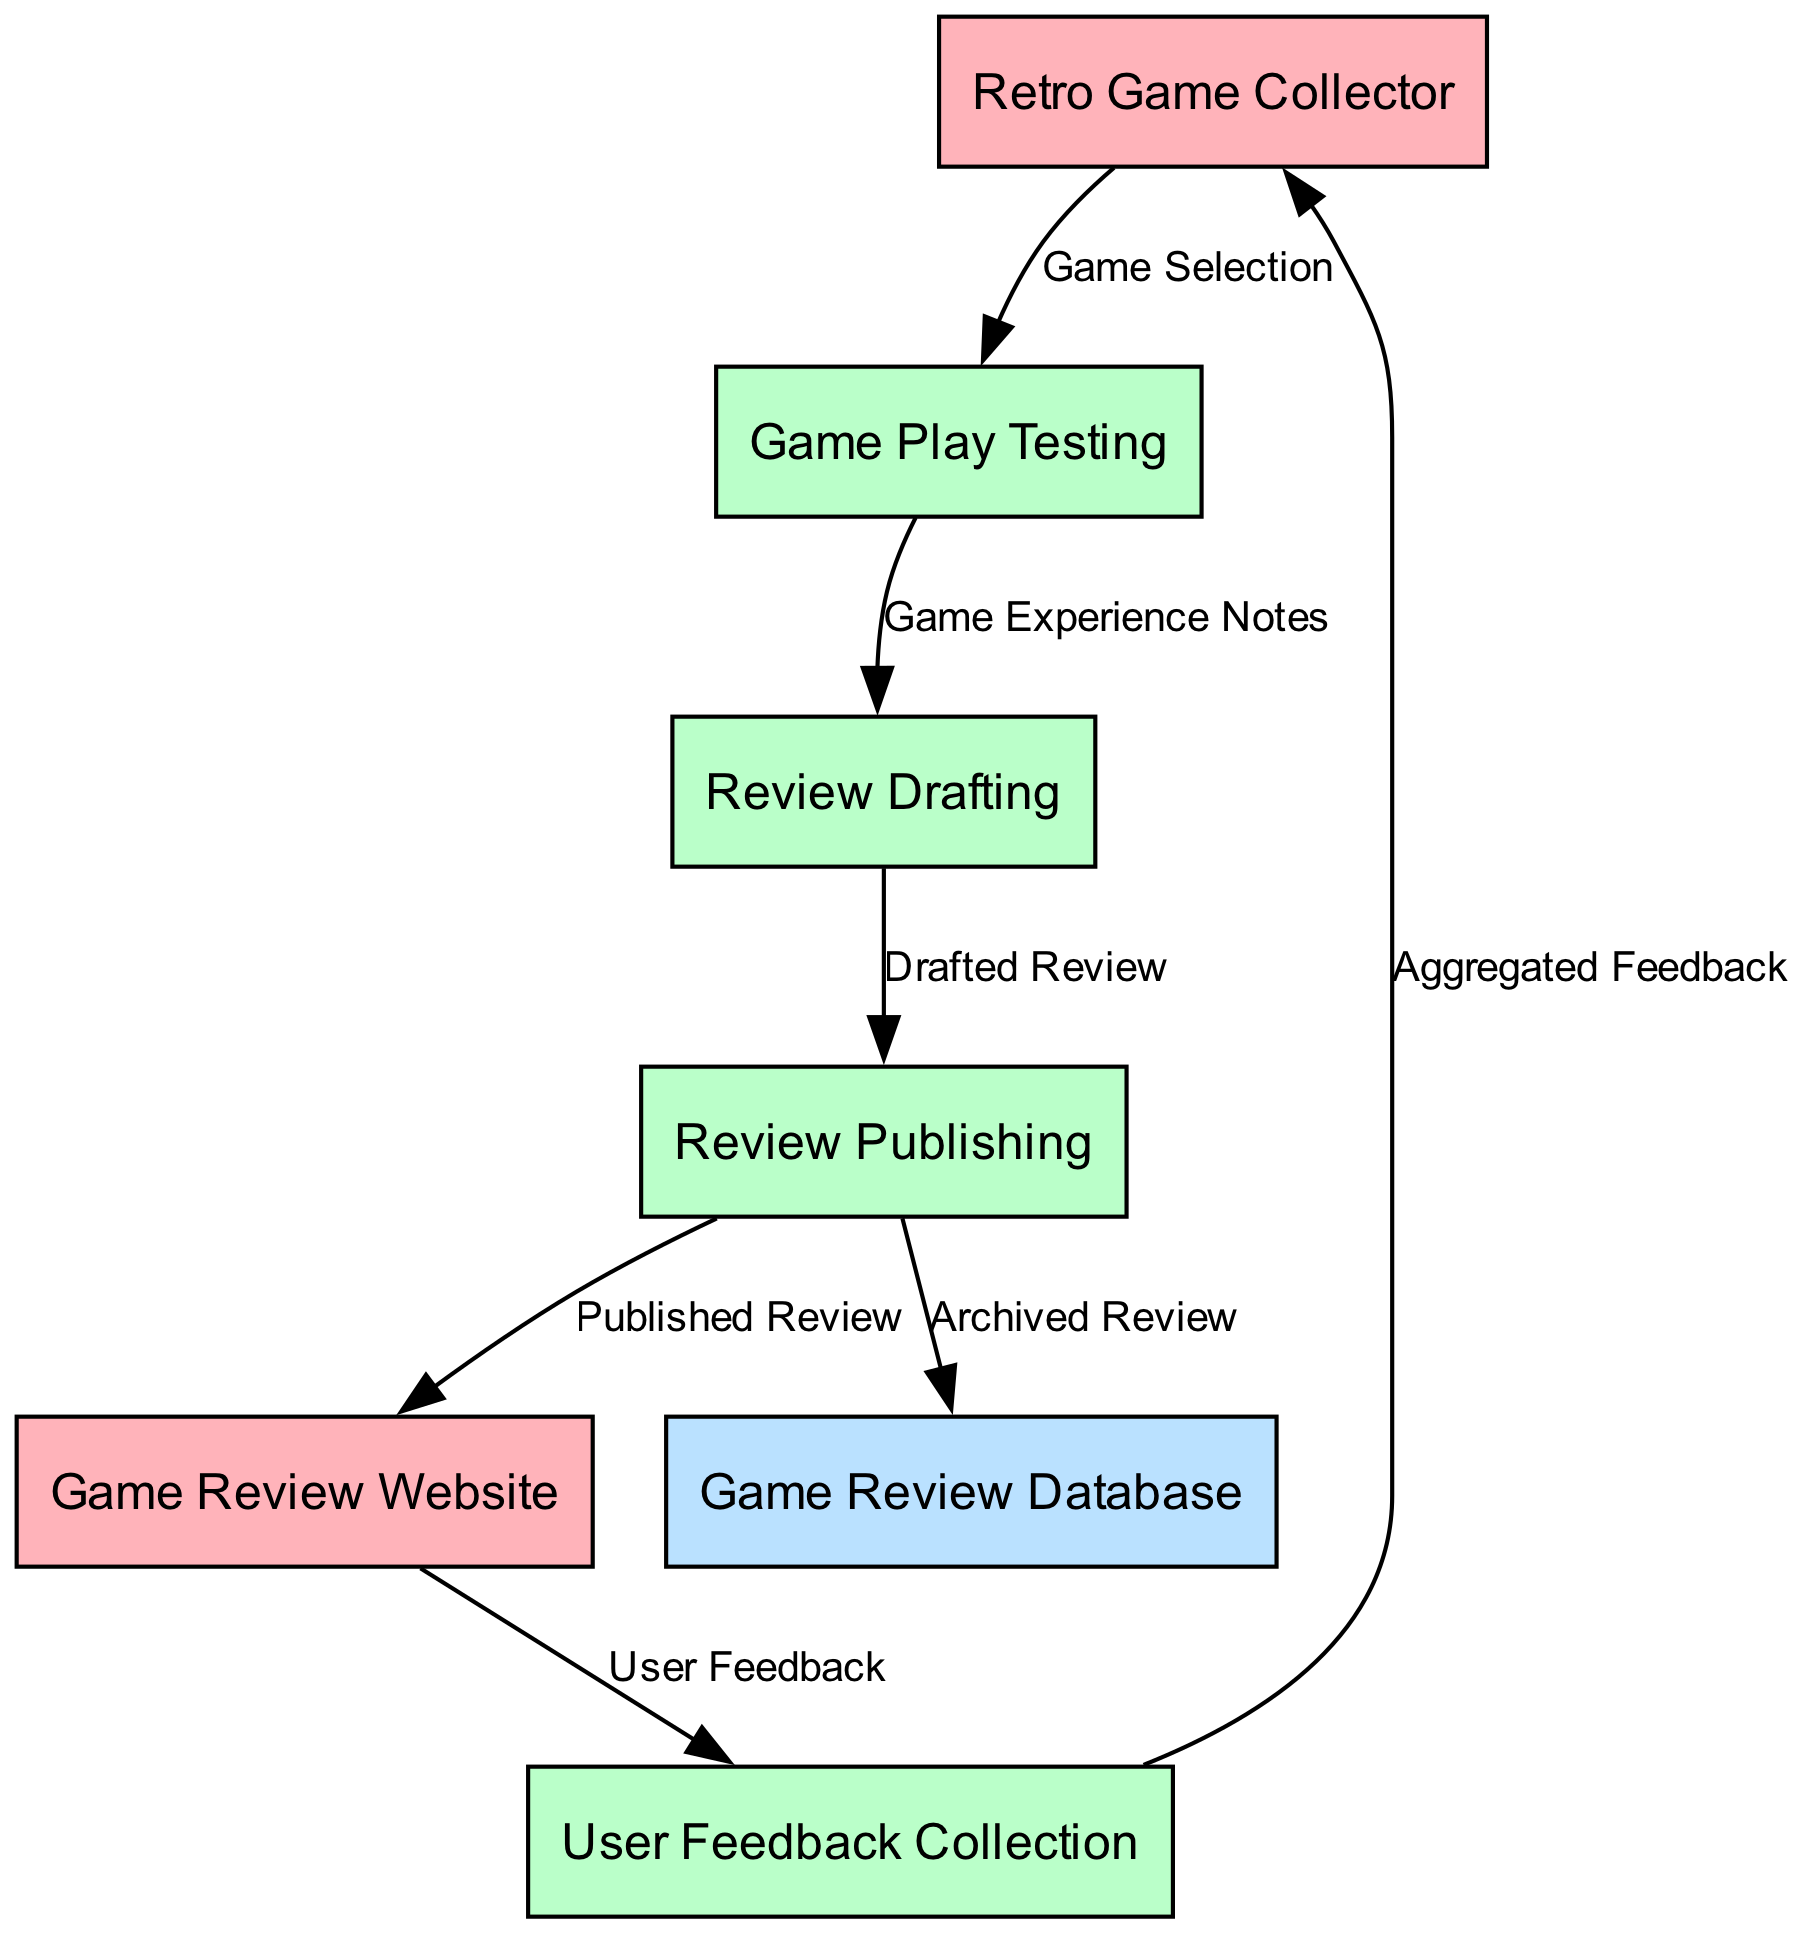What is the total number of nodes in the diagram? The diagram contains six different entities and processes, which are: Retro Game Collector, Game Review Website, Game Review Database, Game Play Testing, Review Drafting, and Review Publishing. Therefore, the total number of nodes is six.
Answer: 6 What type of node is "Game Review Database"? In the diagram, "Game Review Database" is classified under the type "Data Store", as it is used to store archived reviews and serves as a repository for the game reviews.
Answer: Data Store What data flows from "Game Play Testing" to "Review Drafting"? The data that flows from "Game Play Testing" to "Review Drafting" is described as "Game Experience Notes", which represent the information collected during the game play testing process.
Answer: Game Experience Notes Which node sends "User Feedback" to "User Feedback Collection"? The node that sends "User Feedback" to "User Feedback Collection" is the "Game Review Website". It collects feedback from users who have read the reviews and inputs it into the feedback collection process.
Answer: Game Review Website What is the final output of the "Review Publishing" process? The final outputs of the "Review Publishing" process are twofold: it produces a "Published Review" that gets sent to the "Game Review Website" and an "Archived Review" that goes to the "Game Review Database". Thus, the final outputs include both these reviews.
Answer: Published Review, Archived Review What is the order of processes after "Game Play Testing"? The processes that follow "Game Play Testing" in order are: "Review Drafting", then "Review Publishing". This sequential flow indicates that after the gameplay notes are created, reviews are drafted and subsequently published.
Answer: Review Drafting, Review Publishing How many data flows are there in total? By analyzing the data flows listed in the diagram, there are a total of seven connections between the nodes, indicating the paths along which data travels from one node to another in the review process.
Answer: 7 Which entity collects "Aggregated Feedback"? The "Retro Game Collector" is the entity that collects "Aggregated Feedback", which is the compiled user feedback received from the "User Feedback Collection" process.
Answer: Retro Game Collector What is the purpose of the "User Feedback Collection" process? The purpose of the "User Feedback Collection" process is to gather and compile feedback from users who engage with the reviews published on the Game Review Website, helping in enhancing future reviews and recommendations.
Answer: Collect feedback 